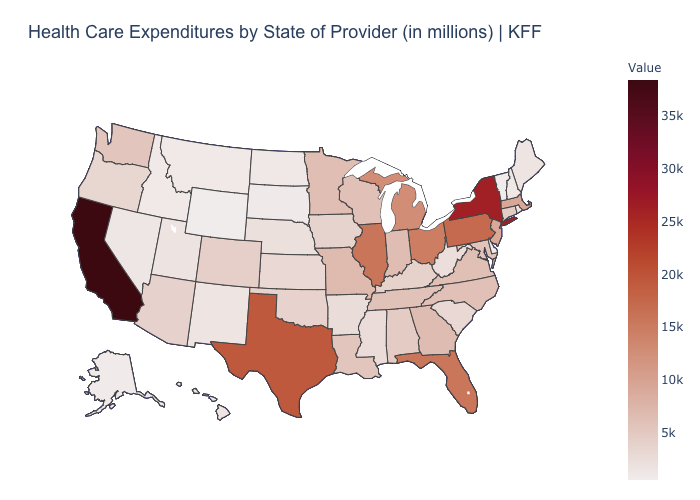Among the states that border New Hampshire , which have the highest value?
Concise answer only. Massachusetts. Which states hav the highest value in the MidWest?
Quick response, please. Illinois. Which states have the highest value in the USA?
Answer briefly. California. Does Delaware have a higher value than Maryland?
Be succinct. No. Does California have the highest value in the USA?
Answer briefly. Yes. 